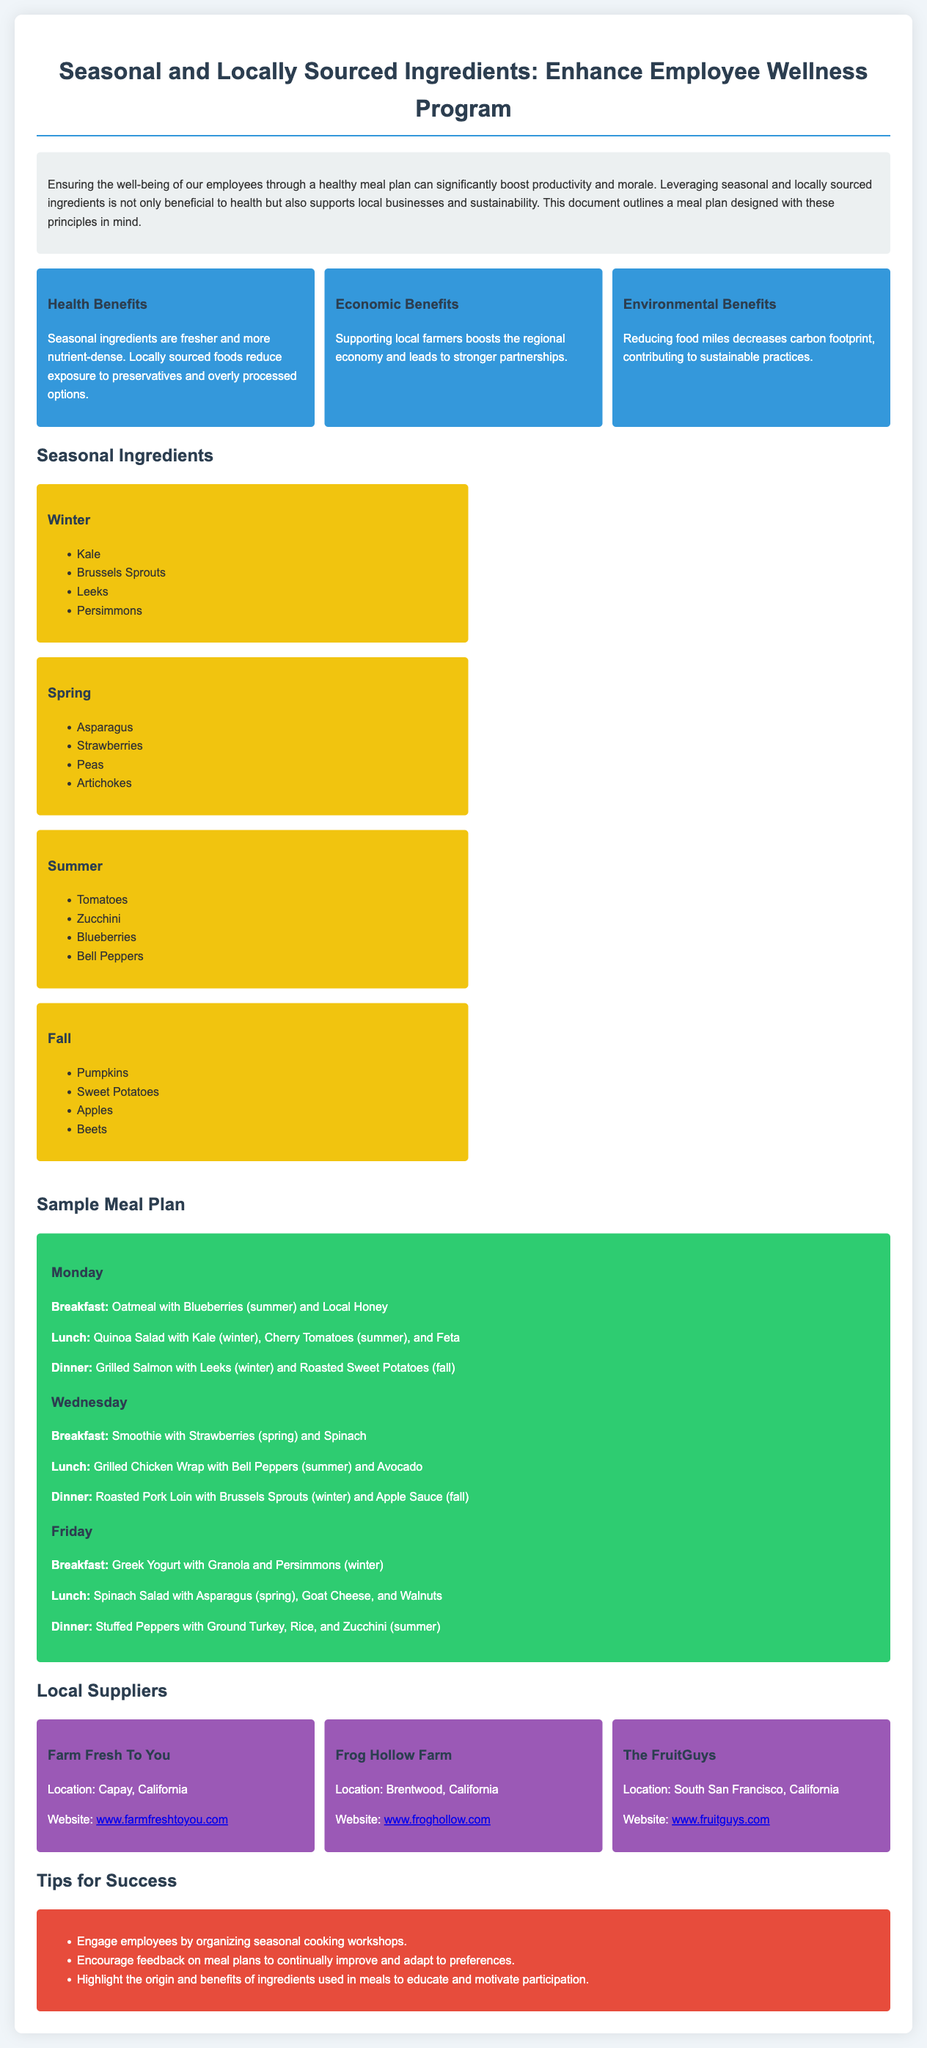What is the title of the document? The title is mentioned at the beginning of the document, highlighting the focus on seasonal and locally sourced ingredients in the employee wellness program.
Answer: Seasonal and Locally Sourced Ingredients: Enhance Employee Wellness Program What are the economic benefits mentioned? The economic benefits are described in a specific section of the document focused on supporting local farmers, which boosts the regional economy and leads to stronger partnerships.
Answer: Supporting local farmers boosts the regional economy and leads to stronger partnerships Which ingredient is listed under Spring? The ingredients for each season are outlined in separate sections, and this question asks for any one item from the Spring section.
Answer: Asparagus What ingredient is included in Monday's dinner? The meal plan sections specify the meals for each day, including dinner options, allowing us to pull specific items from Monday's dinner.
Answer: Grilled Salmon with Leeks and Roasted Sweet Potatoes How many local suppliers are listed? The section discussing local suppliers includes listing and details for each supplier and counts how many are provided in the document.
Answer: 3 What are two tips for success provided in the document? The document outlines specific tips in a distinct section meant to help implement the meal plan successfully.
Answer: Engage employees by organizing seasonal cooking workshops, Encourage feedback on meal plans What type of benefits are mentioned under Health Benefits? The health benefits described in the document point out specific advantages of consuming seasonal ingredients over non-seasonal ones.
Answer: Fresher and more nutrient-dense Which seasonal ingredient is highlighted for Fall? The ingredients listed in the seasonal section outline what is appropriate for Fall, making it clear which ingredient is at the fore.
Answer: Pumpkins 